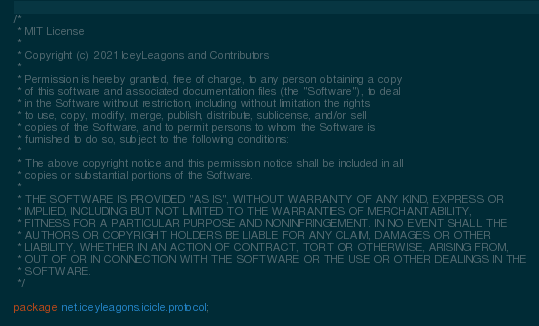Convert code to text. <code><loc_0><loc_0><loc_500><loc_500><_Java_>/*
 * MIT License
 *
 * Copyright (c) 2021 IceyLeagons and Contributors
 *
 * Permission is hereby granted, free of charge, to any person obtaining a copy
 * of this software and associated documentation files (the "Software"), to deal
 * in the Software without restriction, including without limitation the rights
 * to use, copy, modify, merge, publish, distribute, sublicense, and/or sell
 * copies of the Software, and to permit persons to whom the Software is
 * furnished to do so, subject to the following conditions:
 *
 * The above copyright notice and this permission notice shall be included in all
 * copies or substantial portions of the Software.
 *
 * THE SOFTWARE IS PROVIDED "AS IS", WITHOUT WARRANTY OF ANY KIND, EXPRESS OR
 * IMPLIED, INCLUDING BUT NOT LIMITED TO THE WARRANTIES OF MERCHANTABILITY,
 * FITNESS FOR A PARTICULAR PURPOSE AND NONINFRINGEMENT. IN NO EVENT SHALL THE
 * AUTHORS OR COPYRIGHT HOLDERS BE LIABLE FOR ANY CLAIM, DAMAGES OR OTHER
 * LIABILITY, WHETHER IN AN ACTION OF CONTRACT, TORT OR OTHERWISE, ARISING FROM,
 * OUT OF OR IN CONNECTION WITH THE SOFTWARE OR THE USE OR OTHER DEALINGS IN THE
 * SOFTWARE.
 */

package net.iceyleagons.icicle.protocol;
</code> 